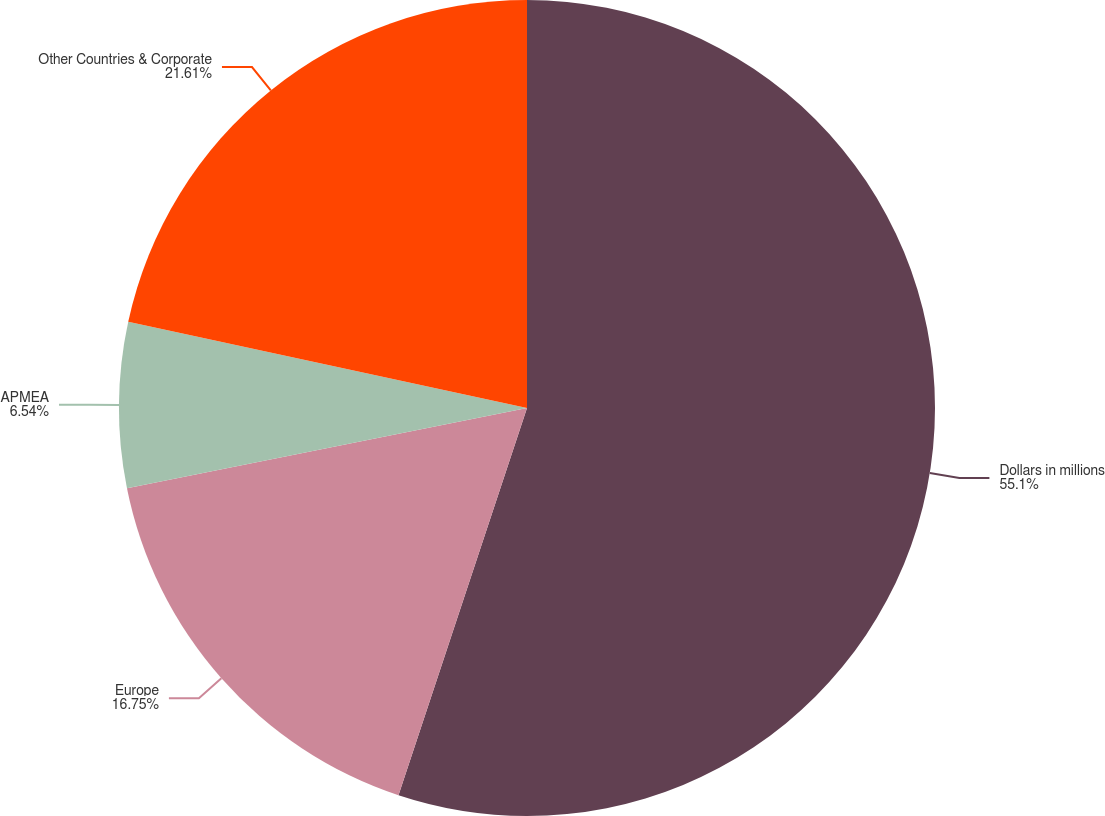Convert chart to OTSL. <chart><loc_0><loc_0><loc_500><loc_500><pie_chart><fcel>Dollars in millions<fcel>Europe<fcel>APMEA<fcel>Other Countries & Corporate<nl><fcel>55.1%<fcel>16.75%<fcel>6.54%<fcel>21.61%<nl></chart> 